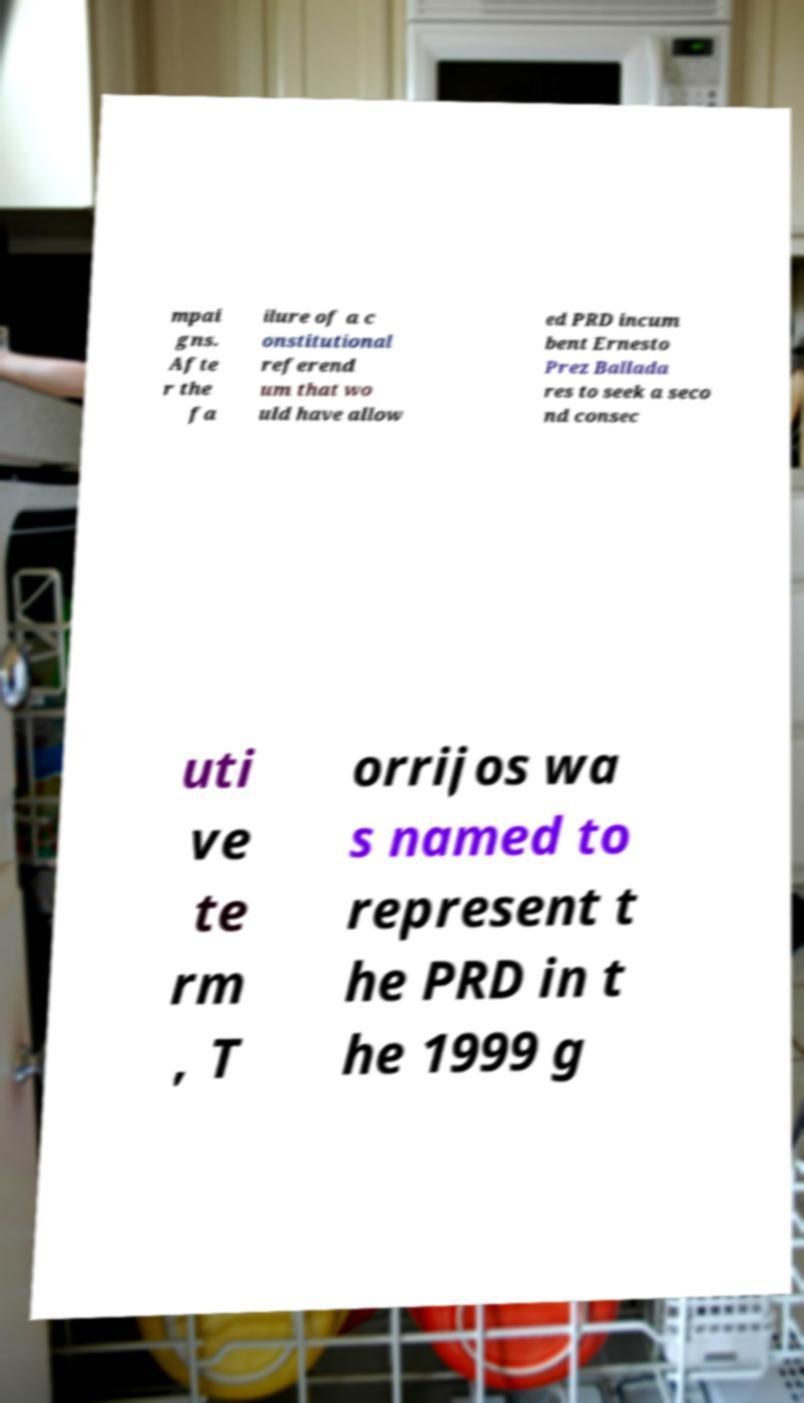Can you accurately transcribe the text from the provided image for me? mpai gns. Afte r the fa ilure of a c onstitutional referend um that wo uld have allow ed PRD incum bent Ernesto Prez Ballada res to seek a seco nd consec uti ve te rm , T orrijos wa s named to represent t he PRD in t he 1999 g 